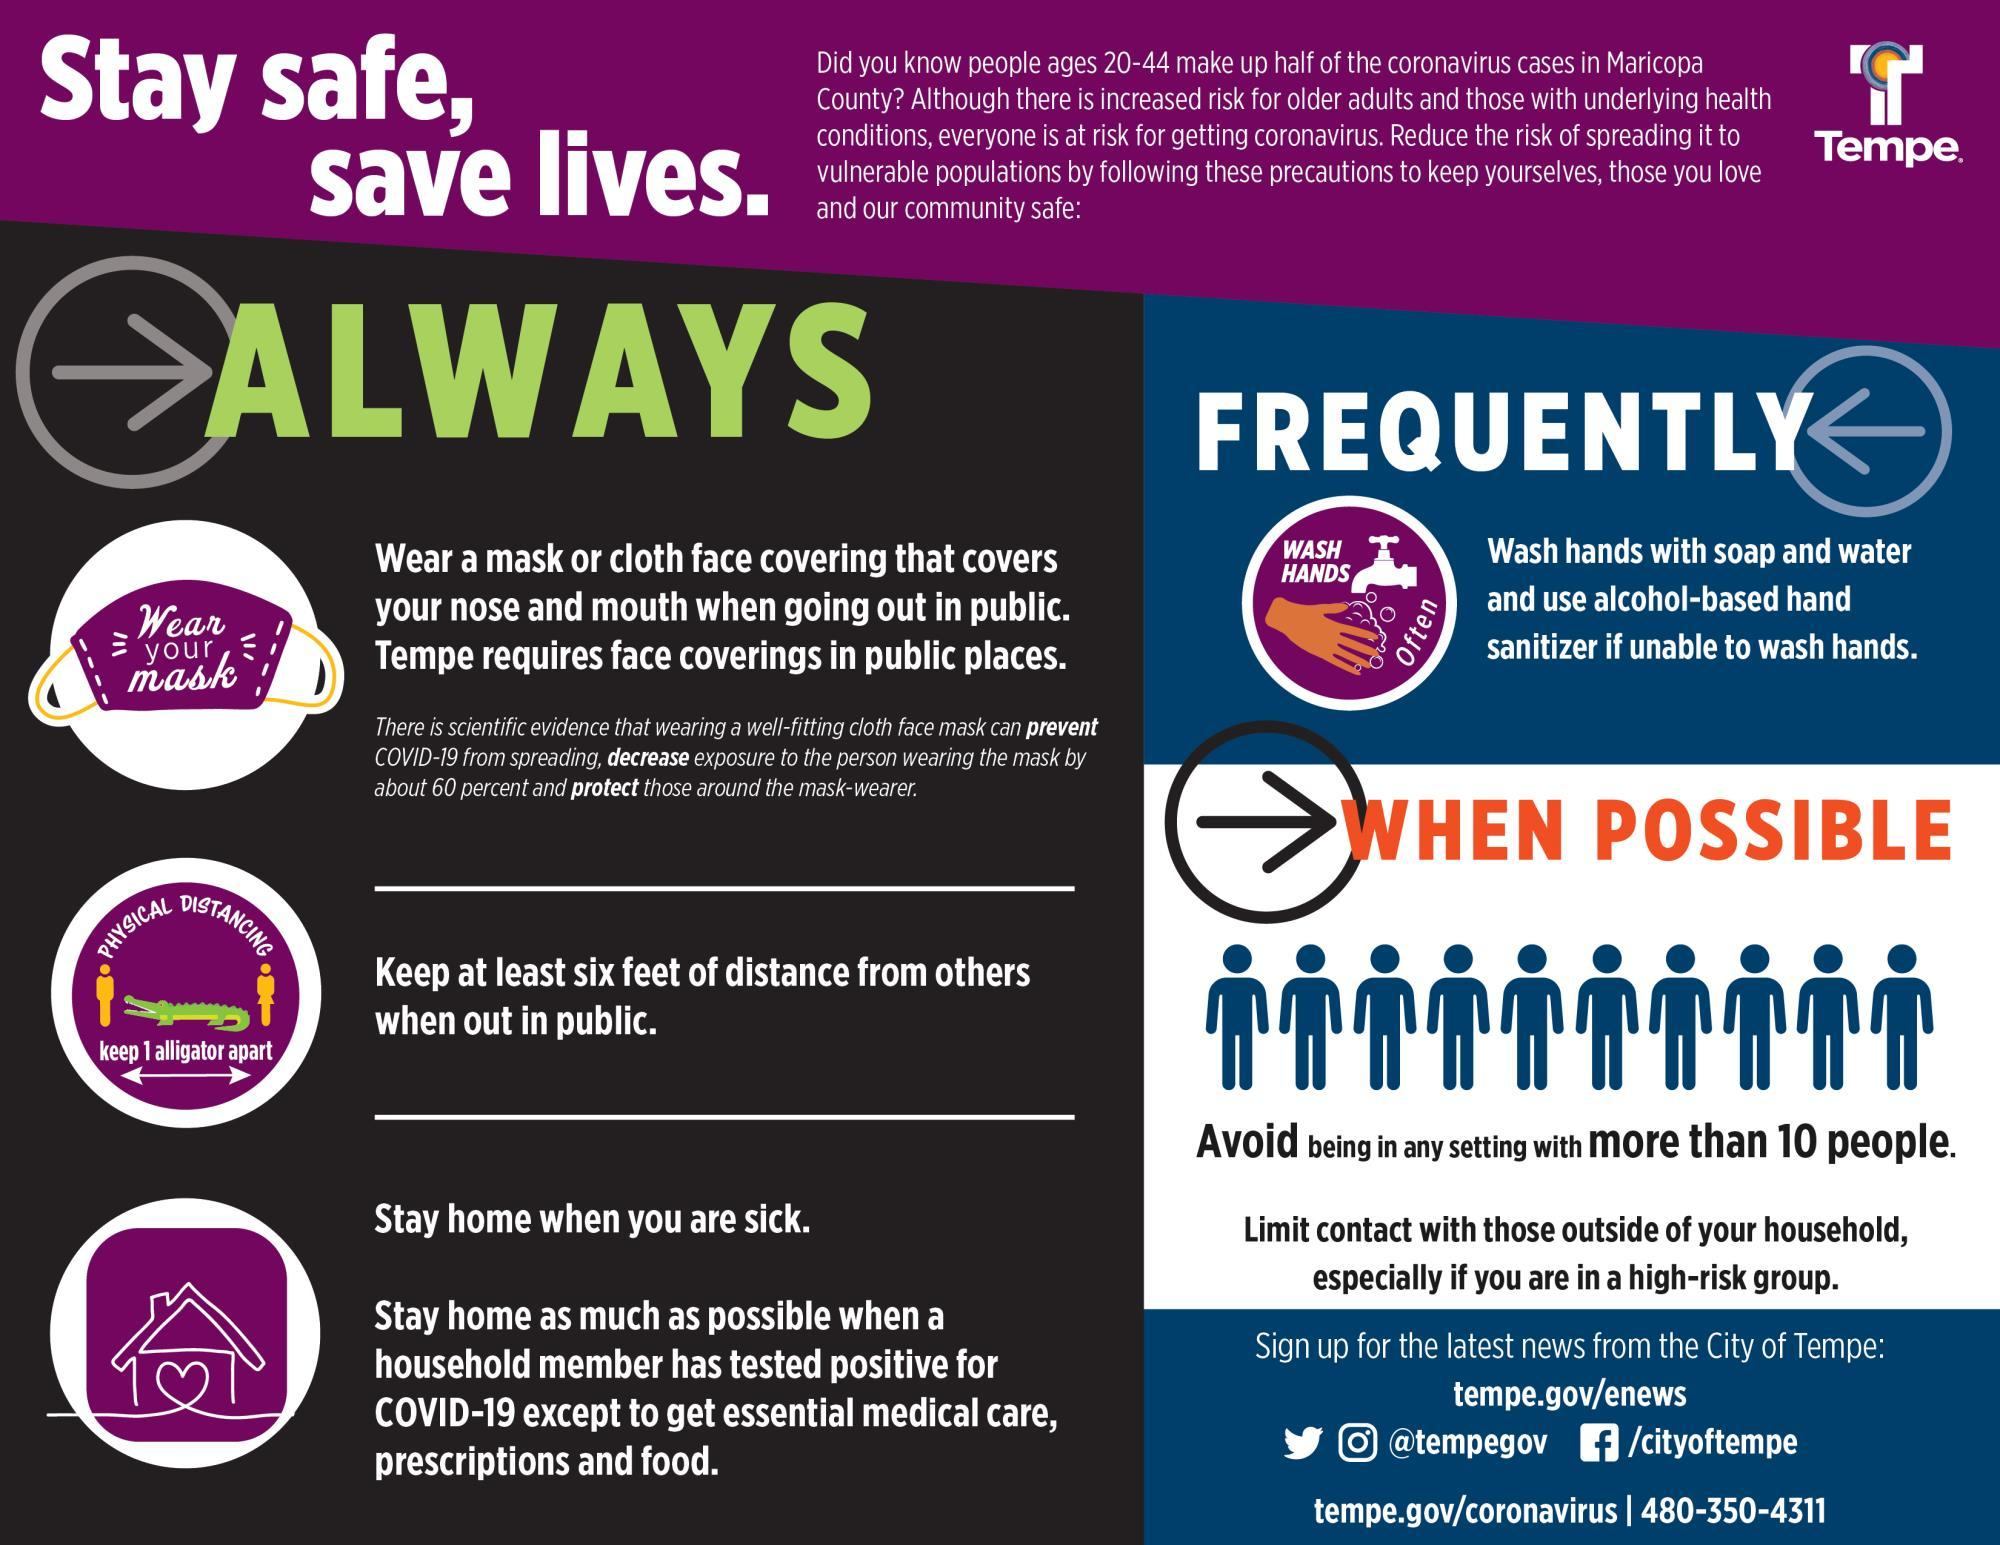List a handful of essential elements in this visual. The length of an alligator is 6 feet. 